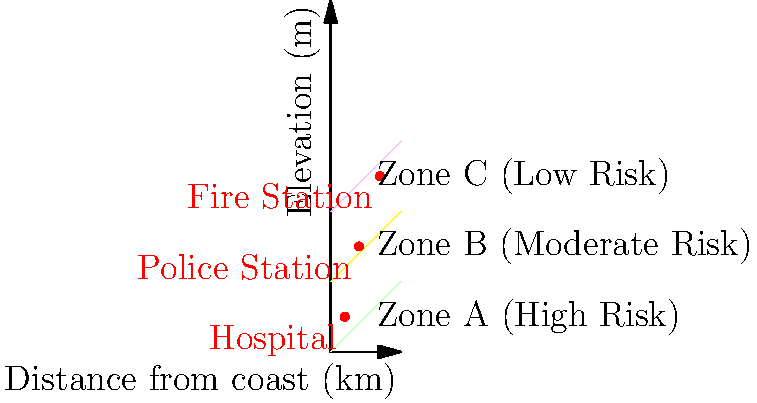Based on the flood zone map provided, which critical infrastructure is most vulnerable to flooding, and what immediate action should be taken to enhance its resilience? To answer this question, we need to analyze the flood zone map and the location of critical infrastructure:

1. Interpret the flood zones:
   - Zone A (green): High risk of flooding
   - Zone B (yellow): Moderate risk of flooding
   - Zone C (pink): Low risk of flooding

2. Identify the location of critical infrastructure:
   - Hospital: Located in Zone A (high risk)
   - Police Station: Located in Zone B (moderate risk)
   - Fire Station: Located in Zone C (low risk)

3. Assess vulnerability:
   - The hospital is in the highest risk zone, making it the most vulnerable to flooding.
   - The police station has moderate risk, while the fire station has the lowest risk.

4. Determine immediate action:
   - Given the hospital's critical role in emergency response and its high vulnerability, it requires immediate attention.
   - To enhance its resilience, we should implement flood protection measures such as:
     a) Installing flood barriers or levees around the hospital
     b) Elevating critical equipment and utilities
     c) Developing an emergency evacuation plan for patients and staff
     d) Ensuring backup power systems are in place and protected from flood waters

5. Long-term considerations:
   - While not part of the immediate action, consider relocating the hospital to a higher elevation in Zone C for long-term resilience.
Answer: Hospital; install flood barriers, elevate equipment, develop evacuation plan, and ensure protected backup power. 